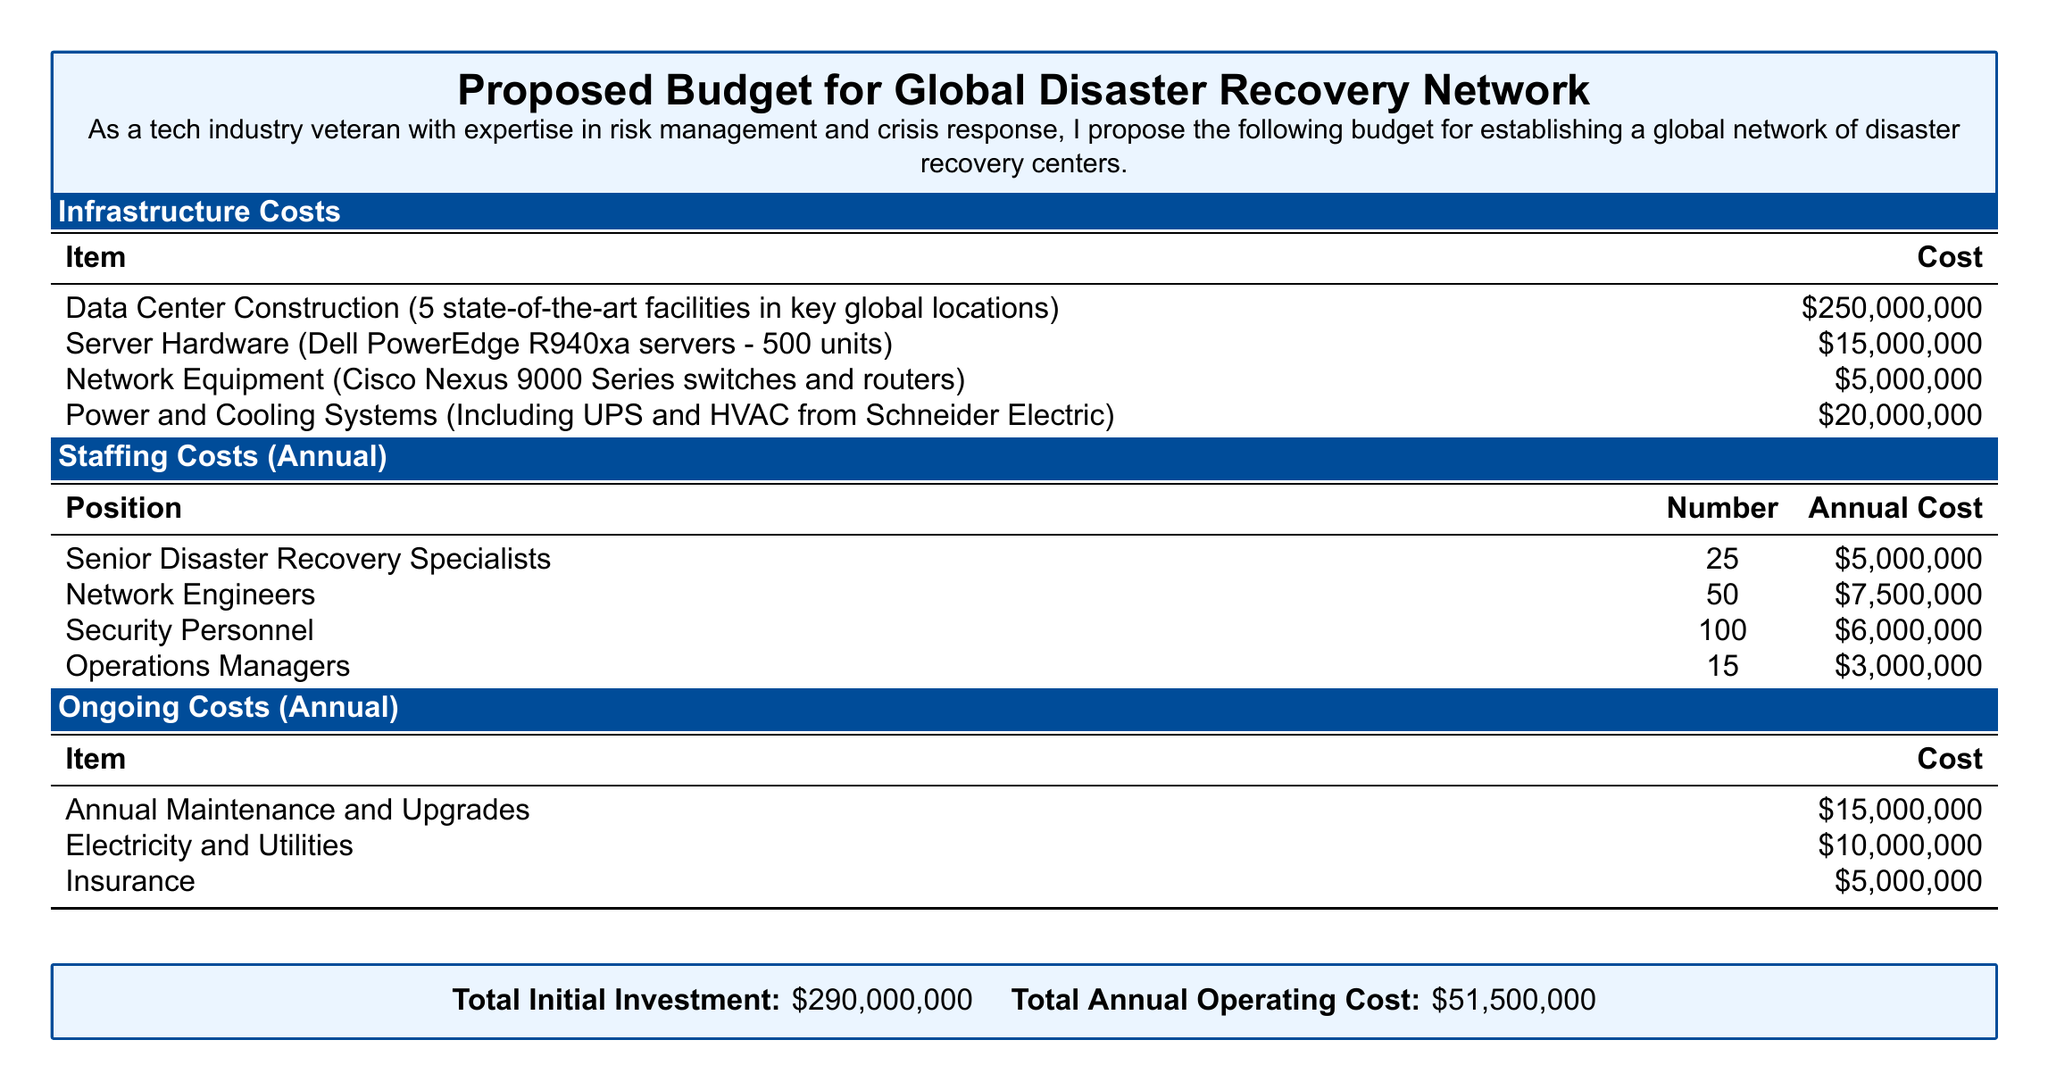What is the total initial investment? The total initial investment is explicitly stated in the document as the sum of all infrastructure and staffing costs.
Answer: $290,000,000 How many senior disaster recovery specialists are proposed? The document lists 25 senior disaster recovery specialists as part of the staffing costs.
Answer: 25 What is the cost of data center construction? The document specifies that the cost of constructing 5 facilities is $250,000,000.
Answer: $250,000,000 What is the annual cost for electricity and utilities? The document states that the annual cost for electricity and utilities is $10,000,000.
Answer: $10,000,000 What is the total annual operating cost? The total annual operating cost is provided as the sum of all ongoing costs, which amounts to $51,500,000.
Answer: $51,500,000 How many positions of network engineers are included? The document indicates there are 50 network engineers as part of the staffing costs.
Answer: 50 What type of network equipment is mentioned? The document mentions Cisco Nexus 9000 Series switches and routers as the network equipment.
Answer: Cisco Nexus 9000 Series switches and routers What is the cost for annual maintenance and upgrades? The document specifies that annual maintenance and upgrades cost $15,000,000.
Answer: $15,000,000 How many total positions of security personnel are proposed? The document states that there are 100 security personnel included in the staffing costs.
Answer: 100 